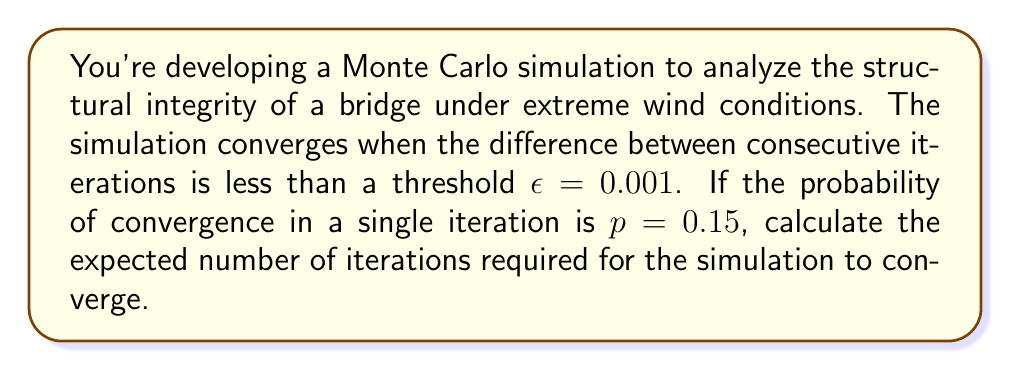Can you answer this question? Let's approach this step-by-step:

1) This scenario follows a geometric distribution, where we're counting the number of trials (iterations) until the first success (convergence).

2) For a geometric distribution, the expected value (mean) is given by:

   $$E(X) = \frac{1}{p}$$

   where $p$ is the probability of success on each trial.

3) In this case, $p = 0.15$

4) Substituting this into our formula:

   $$E(X) = \frac{1}{0.15}$$

5) Calculating this:

   $$E(X) = 6.6666...$$

6) Since we're dealing with iterations, which must be whole numbers, we round up to the nearest integer.

Therefore, the expected number of iterations for the Monte Carlo simulation to converge is 7.
Answer: 7 iterations 